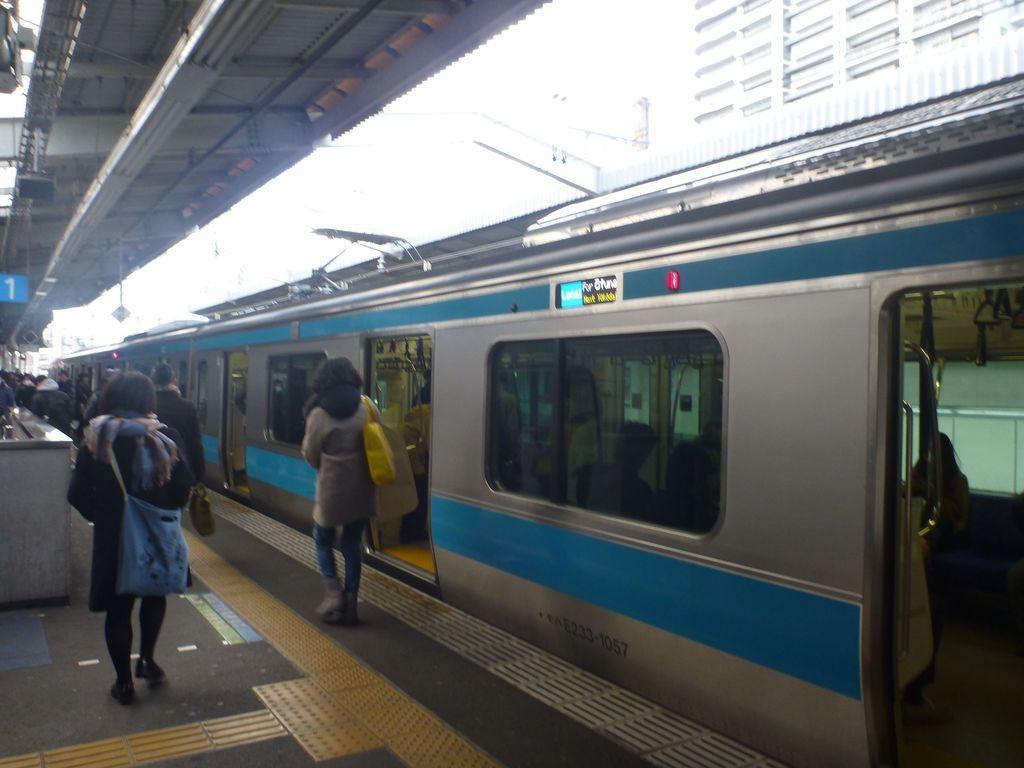How would you summarize this image in a sentence or two? In this image I can see a platform in the front and on it I can see number of people are standing. I can also see a train in the background and in it I can see few people. On the left side of the image I can see a blue colour board and on it I can see something is written. 